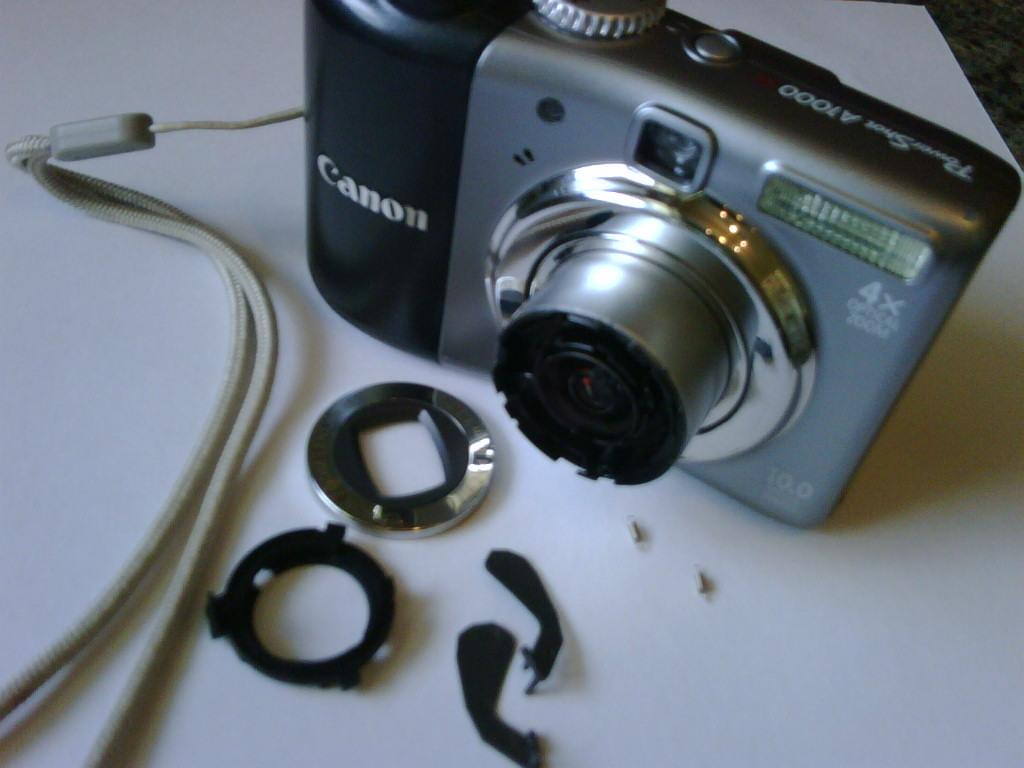What is the main subject of the image? The main subject of the image is a camera. What is the camera placed on in the image? The camera is placed on a white color object. What type of lumber is visible in the image? There is no lumber present in the image. How many sticks are used to support the camera in the image? There are no sticks used to support the camera in the image; it is placed on a white color object. 